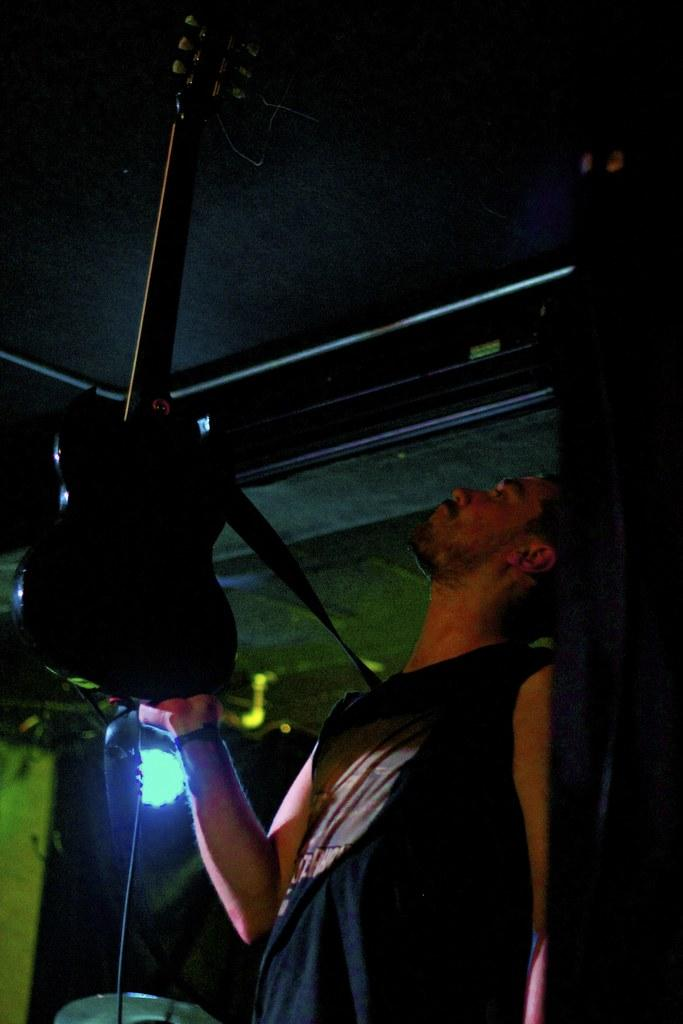What is the person in the image doing? The person is holding a guitar. What can be seen in the background of the image? There is a light, a ceiling, and other objects visible in the background. Can you describe the light in the background? The light is simply described as being present in the background. What type of shirt is the person wearing in the image? The provided facts do not mention the person's shirt, so we cannot determine the type of shirt they are wearing. How many cats are visible in the image? There are no cats present in the image. 